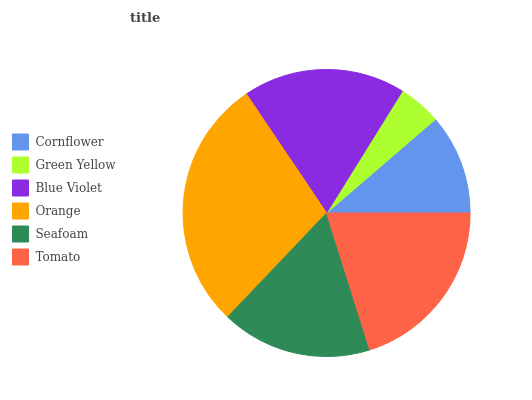Is Green Yellow the minimum?
Answer yes or no. Yes. Is Orange the maximum?
Answer yes or no. Yes. Is Blue Violet the minimum?
Answer yes or no. No. Is Blue Violet the maximum?
Answer yes or no. No. Is Blue Violet greater than Green Yellow?
Answer yes or no. Yes. Is Green Yellow less than Blue Violet?
Answer yes or no. Yes. Is Green Yellow greater than Blue Violet?
Answer yes or no. No. Is Blue Violet less than Green Yellow?
Answer yes or no. No. Is Blue Violet the high median?
Answer yes or no. Yes. Is Seafoam the low median?
Answer yes or no. Yes. Is Cornflower the high median?
Answer yes or no. No. Is Tomato the low median?
Answer yes or no. No. 